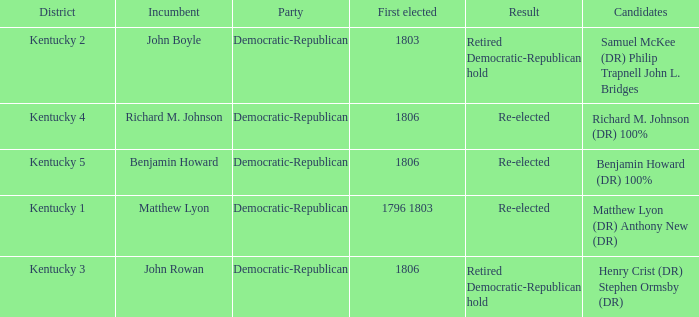Would you be able to parse every entry in this table? {'header': ['District', 'Incumbent', 'Party', 'First elected', 'Result', 'Candidates'], 'rows': [['Kentucky 2', 'John Boyle', 'Democratic-Republican', '1803', 'Retired Democratic-Republican hold', 'Samuel McKee (DR) Philip Trapnell John L. Bridges'], ['Kentucky 4', 'Richard M. Johnson', 'Democratic-Republican', '1806', 'Re-elected', 'Richard M. Johnson (DR) 100%'], ['Kentucky 5', 'Benjamin Howard', 'Democratic-Republican', '1806', 'Re-elected', 'Benjamin Howard (DR) 100%'], ['Kentucky 1', 'Matthew Lyon', 'Democratic-Republican', '1796 1803', 'Re-elected', 'Matthew Lyon (DR) Anthony New (DR)'], ['Kentucky 3', 'John Rowan', 'Democratic-Republican', '1806', 'Retired Democratic-Republican hold', 'Henry Crist (DR) Stephen Ormsby (DR)']]} Name the first elected for kentucky 1 1796 1803. 